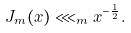<formula> <loc_0><loc_0><loc_500><loc_500>J _ { m } ( x ) \lll _ { m } x ^ { - \frac { 1 } { 2 } } .</formula> 